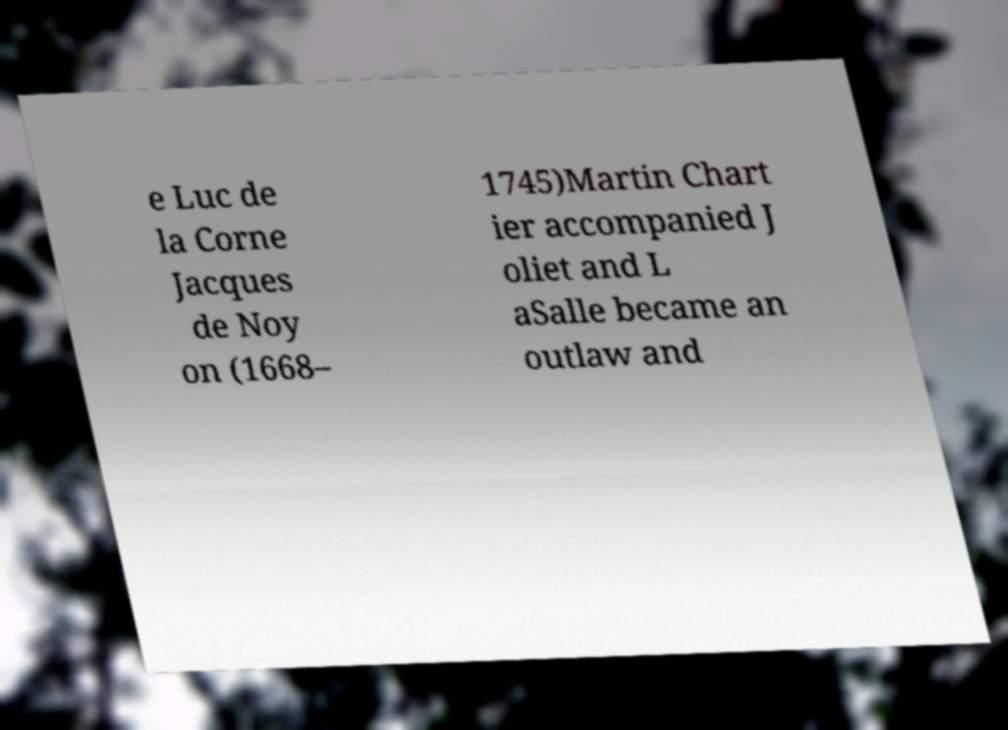For documentation purposes, I need the text within this image transcribed. Could you provide that? e Luc de la Corne Jacques de Noy on (1668– 1745)Martin Chart ier accompanied J oliet and L aSalle became an outlaw and 